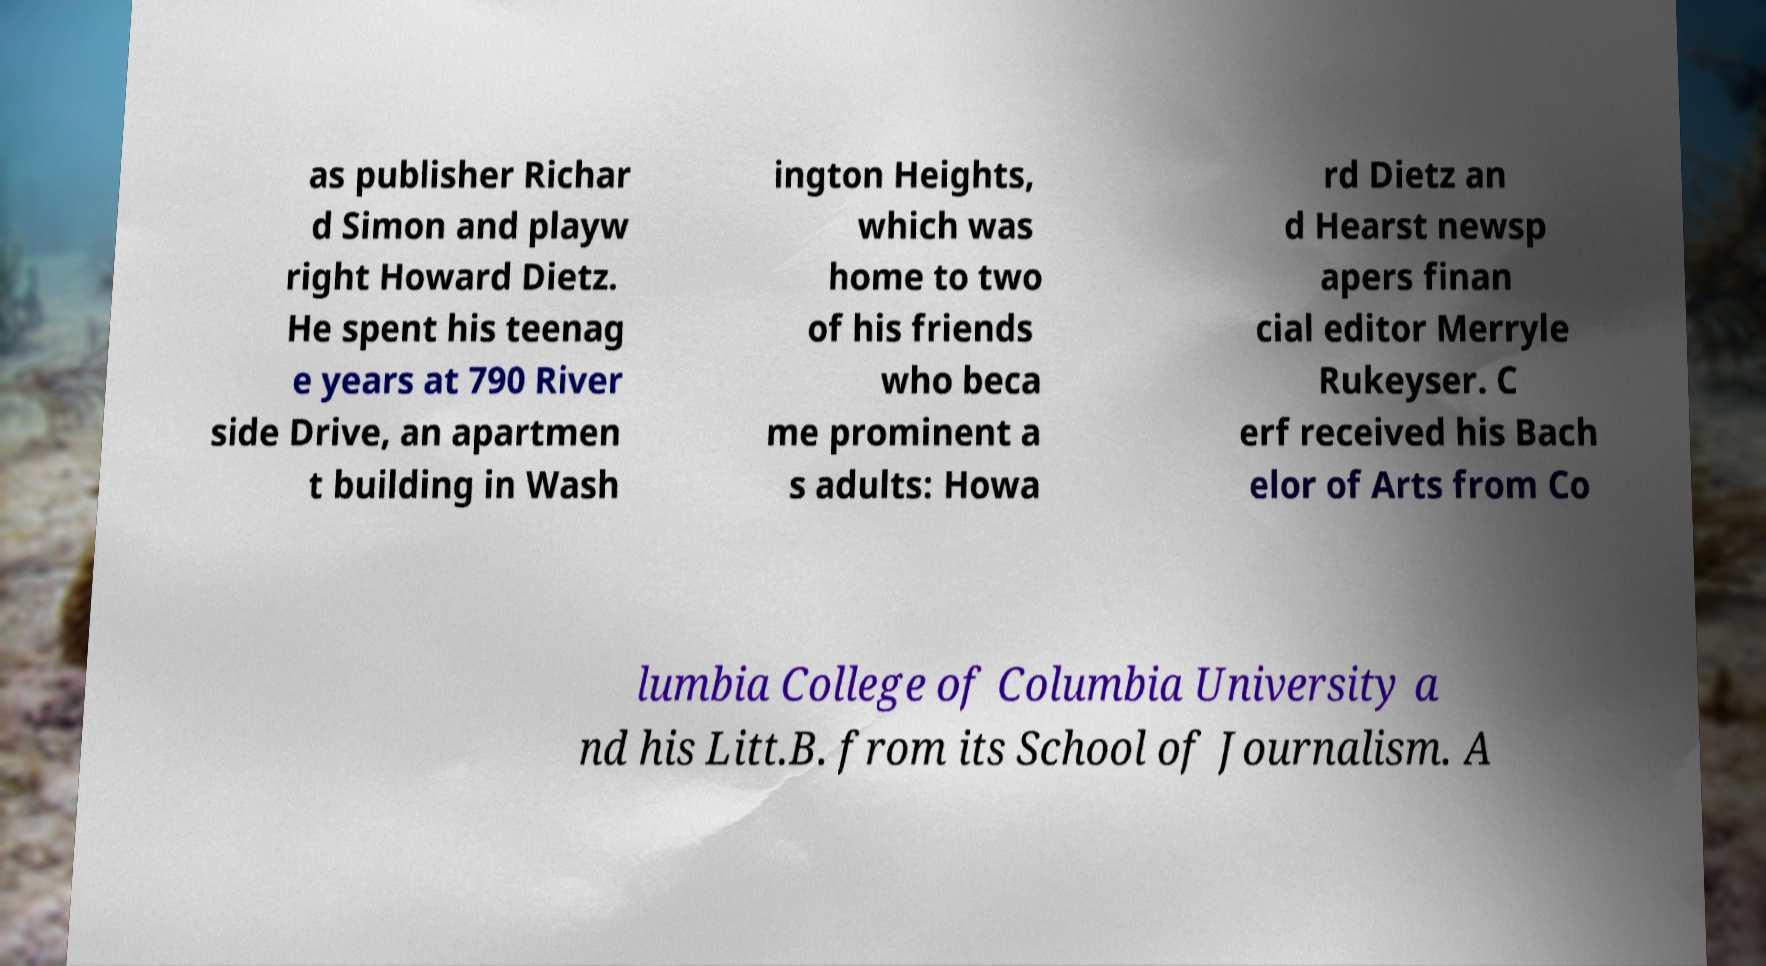Could you extract and type out the text from this image? as publisher Richar d Simon and playw right Howard Dietz. He spent his teenag e years at 790 River side Drive, an apartmen t building in Wash ington Heights, which was home to two of his friends who beca me prominent a s adults: Howa rd Dietz an d Hearst newsp apers finan cial editor Merryle Rukeyser. C erf received his Bach elor of Arts from Co lumbia College of Columbia University a nd his Litt.B. from its School of Journalism. A 